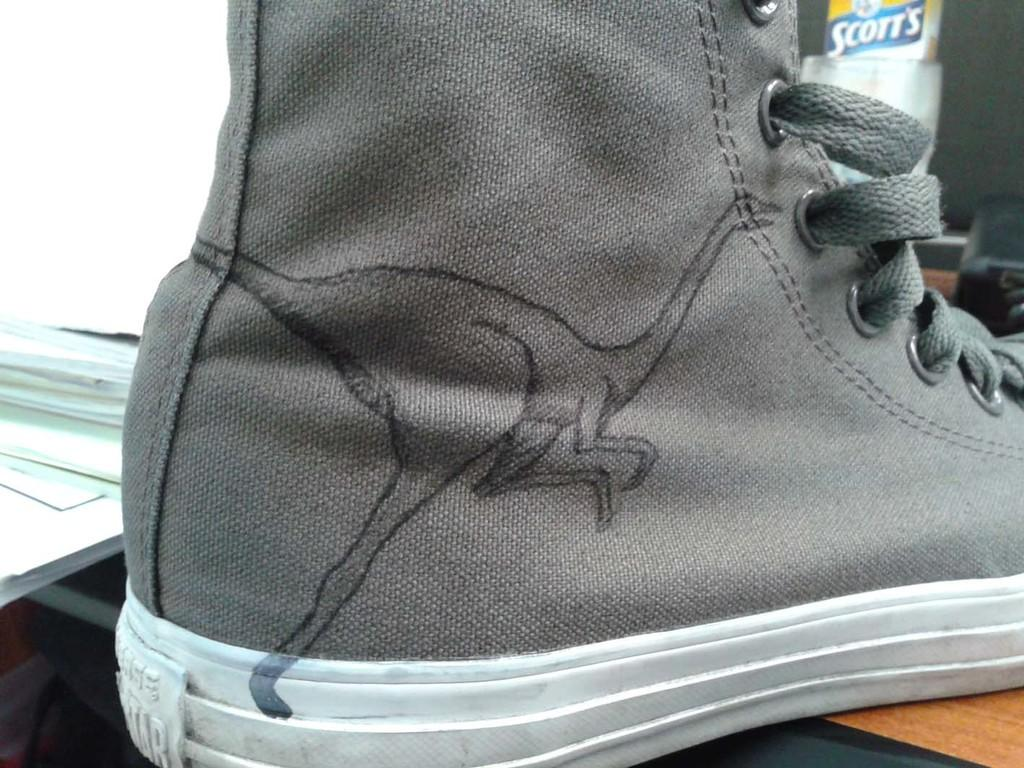What object is the main subject of the image? There is a shoe in the image. Where is the shoe located? The shoe is placed on a wooden surface. How many books are stacked next to the shoe in the image? There are no books present in the image; it only features a shoe placed on a wooden surface. 